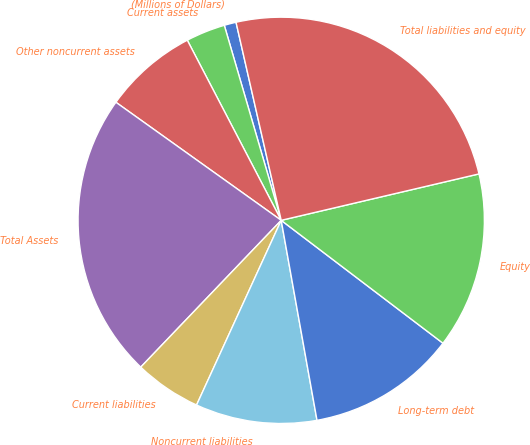Convert chart. <chart><loc_0><loc_0><loc_500><loc_500><pie_chart><fcel>(Millions of Dollars)<fcel>Current assets<fcel>Other noncurrent assets<fcel>Total Assets<fcel>Current liabilities<fcel>Noncurrent liabilities<fcel>Long-term debt<fcel>Equity<fcel>Total liabilities and equity<nl><fcel>0.95%<fcel>3.13%<fcel>7.48%<fcel>22.72%<fcel>5.31%<fcel>9.66%<fcel>11.84%<fcel>14.01%<fcel>24.9%<nl></chart> 